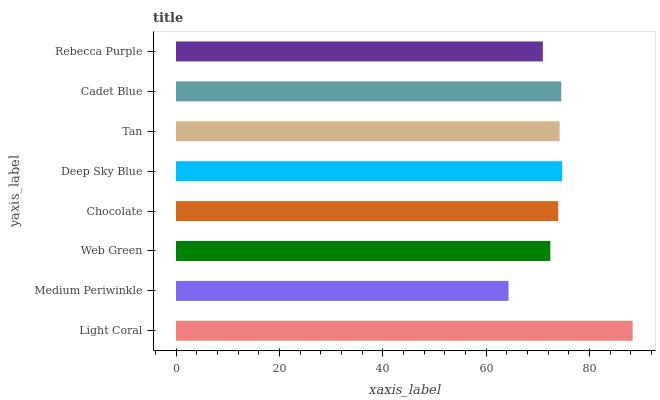Is Medium Periwinkle the minimum?
Answer yes or no. Yes. Is Light Coral the maximum?
Answer yes or no. Yes. Is Web Green the minimum?
Answer yes or no. No. Is Web Green the maximum?
Answer yes or no. No. Is Web Green greater than Medium Periwinkle?
Answer yes or no. Yes. Is Medium Periwinkle less than Web Green?
Answer yes or no. Yes. Is Medium Periwinkle greater than Web Green?
Answer yes or no. No. Is Web Green less than Medium Periwinkle?
Answer yes or no. No. Is Tan the high median?
Answer yes or no. Yes. Is Chocolate the low median?
Answer yes or no. Yes. Is Light Coral the high median?
Answer yes or no. No. Is Medium Periwinkle the low median?
Answer yes or no. No. 